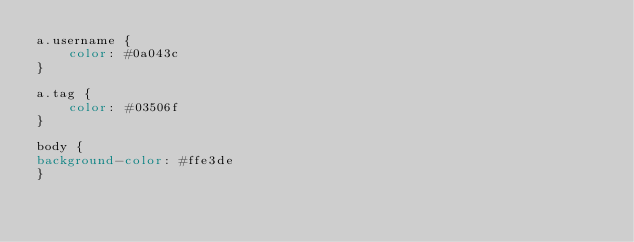<code> <loc_0><loc_0><loc_500><loc_500><_CSS_>a.username {
    color: #0a043c
}

a.tag {
    color: #03506f
}

body {
background-color: #ffe3de
}</code> 